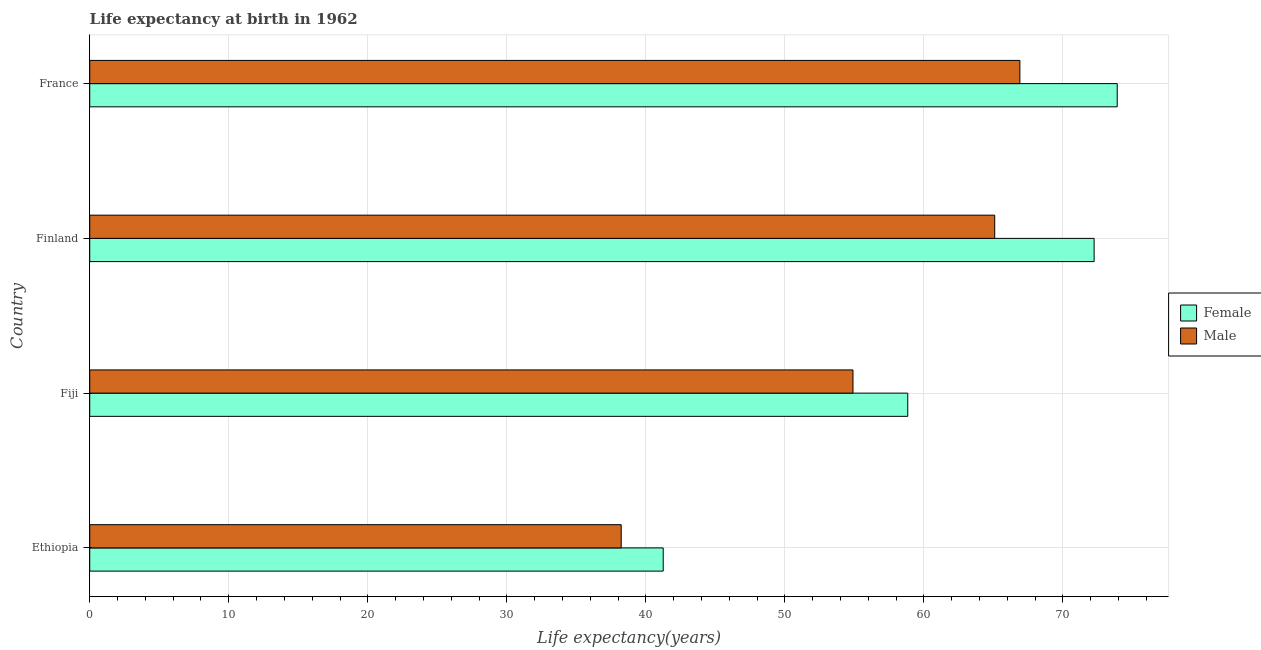How many bars are there on the 4th tick from the top?
Give a very brief answer. 2. How many bars are there on the 3rd tick from the bottom?
Provide a succinct answer. 2. What is the label of the 3rd group of bars from the top?
Provide a short and direct response. Fiji. In how many cases, is the number of bars for a given country not equal to the number of legend labels?
Give a very brief answer. 0. What is the life expectancy(female) in Ethiopia?
Offer a very short reply. 41.25. Across all countries, what is the maximum life expectancy(female)?
Provide a succinct answer. 73.9. Across all countries, what is the minimum life expectancy(female)?
Make the answer very short. 41.25. In which country was the life expectancy(female) maximum?
Your response must be concise. France. In which country was the life expectancy(male) minimum?
Ensure brevity in your answer.  Ethiopia. What is the total life expectancy(female) in the graph?
Make the answer very short. 246.22. What is the difference between the life expectancy(male) in Ethiopia and that in Fiji?
Ensure brevity in your answer.  -16.67. What is the difference between the life expectancy(male) in Finland and the life expectancy(female) in France?
Give a very brief answer. -8.81. What is the average life expectancy(female) per country?
Provide a succinct answer. 61.55. What is the difference between the life expectancy(female) and life expectancy(male) in France?
Offer a terse response. 7. In how many countries, is the life expectancy(male) greater than 22 years?
Your answer should be compact. 4. What is the ratio of the life expectancy(male) in Fiji to that in France?
Offer a terse response. 0.82. Is the difference between the life expectancy(male) in Fiji and France greater than the difference between the life expectancy(female) in Fiji and France?
Make the answer very short. Yes. What is the difference between the highest and the second highest life expectancy(male)?
Your response must be concise. 1.81. What is the difference between the highest and the lowest life expectancy(male)?
Provide a short and direct response. 28.68. What does the 2nd bar from the bottom in France represents?
Ensure brevity in your answer.  Male. How many bars are there?
Keep it short and to the point. 8. What is the difference between two consecutive major ticks on the X-axis?
Offer a terse response. 10. Does the graph contain any zero values?
Make the answer very short. No. Does the graph contain grids?
Offer a terse response. Yes. Where does the legend appear in the graph?
Keep it short and to the point. Center right. How many legend labels are there?
Offer a terse response. 2. What is the title of the graph?
Make the answer very short. Life expectancy at birth in 1962. Does "Register a property" appear as one of the legend labels in the graph?
Offer a terse response. No. What is the label or title of the X-axis?
Your answer should be compact. Life expectancy(years). What is the Life expectancy(years) of Female in Ethiopia?
Give a very brief answer. 41.25. What is the Life expectancy(years) of Male in Ethiopia?
Keep it short and to the point. 38.23. What is the Life expectancy(years) of Female in Fiji?
Your response must be concise. 58.84. What is the Life expectancy(years) of Male in Fiji?
Provide a succinct answer. 54.9. What is the Life expectancy(years) of Female in Finland?
Provide a short and direct response. 72.24. What is the Life expectancy(years) in Male in Finland?
Keep it short and to the point. 65.09. What is the Life expectancy(years) in Female in France?
Offer a terse response. 73.9. What is the Life expectancy(years) of Male in France?
Provide a short and direct response. 66.9. Across all countries, what is the maximum Life expectancy(years) in Female?
Keep it short and to the point. 73.9. Across all countries, what is the maximum Life expectancy(years) in Male?
Your response must be concise. 66.9. Across all countries, what is the minimum Life expectancy(years) of Female?
Keep it short and to the point. 41.25. Across all countries, what is the minimum Life expectancy(years) of Male?
Make the answer very short. 38.23. What is the total Life expectancy(years) of Female in the graph?
Give a very brief answer. 246.22. What is the total Life expectancy(years) of Male in the graph?
Make the answer very short. 225.11. What is the difference between the Life expectancy(years) of Female in Ethiopia and that in Fiji?
Provide a short and direct response. -17.59. What is the difference between the Life expectancy(years) of Male in Ethiopia and that in Fiji?
Offer a very short reply. -16.67. What is the difference between the Life expectancy(years) of Female in Ethiopia and that in Finland?
Provide a short and direct response. -30.99. What is the difference between the Life expectancy(years) of Male in Ethiopia and that in Finland?
Keep it short and to the point. -26.86. What is the difference between the Life expectancy(years) of Female in Ethiopia and that in France?
Provide a short and direct response. -32.65. What is the difference between the Life expectancy(years) of Male in Ethiopia and that in France?
Your response must be concise. -28.68. What is the difference between the Life expectancy(years) of Female in Fiji and that in Finland?
Your response must be concise. -13.4. What is the difference between the Life expectancy(years) of Male in Fiji and that in Finland?
Offer a terse response. -10.19. What is the difference between the Life expectancy(years) of Female in Fiji and that in France?
Offer a very short reply. -15.06. What is the difference between the Life expectancy(years) of Male in Fiji and that in France?
Your answer should be compact. -12. What is the difference between the Life expectancy(years) in Female in Finland and that in France?
Your answer should be compact. -1.66. What is the difference between the Life expectancy(years) of Male in Finland and that in France?
Your response must be concise. -1.81. What is the difference between the Life expectancy(years) in Female in Ethiopia and the Life expectancy(years) in Male in Fiji?
Provide a short and direct response. -13.65. What is the difference between the Life expectancy(years) of Female in Ethiopia and the Life expectancy(years) of Male in Finland?
Provide a short and direct response. -23.84. What is the difference between the Life expectancy(years) in Female in Ethiopia and the Life expectancy(years) in Male in France?
Your answer should be very brief. -25.65. What is the difference between the Life expectancy(years) of Female in Fiji and the Life expectancy(years) of Male in Finland?
Provide a short and direct response. -6.25. What is the difference between the Life expectancy(years) of Female in Fiji and the Life expectancy(years) of Male in France?
Offer a terse response. -8.06. What is the difference between the Life expectancy(years) in Female in Finland and the Life expectancy(years) in Male in France?
Give a very brief answer. 5.34. What is the average Life expectancy(years) in Female per country?
Give a very brief answer. 61.56. What is the average Life expectancy(years) in Male per country?
Give a very brief answer. 56.28. What is the difference between the Life expectancy(years) of Female and Life expectancy(years) of Male in Ethiopia?
Provide a succinct answer. 3.02. What is the difference between the Life expectancy(years) of Female and Life expectancy(years) of Male in Fiji?
Give a very brief answer. 3.94. What is the difference between the Life expectancy(years) of Female and Life expectancy(years) of Male in Finland?
Offer a very short reply. 7.15. What is the ratio of the Life expectancy(years) in Female in Ethiopia to that in Fiji?
Provide a succinct answer. 0.7. What is the ratio of the Life expectancy(years) of Male in Ethiopia to that in Fiji?
Keep it short and to the point. 0.7. What is the ratio of the Life expectancy(years) in Female in Ethiopia to that in Finland?
Your answer should be very brief. 0.57. What is the ratio of the Life expectancy(years) in Male in Ethiopia to that in Finland?
Your answer should be very brief. 0.59. What is the ratio of the Life expectancy(years) in Female in Ethiopia to that in France?
Offer a terse response. 0.56. What is the ratio of the Life expectancy(years) of Male in Ethiopia to that in France?
Ensure brevity in your answer.  0.57. What is the ratio of the Life expectancy(years) of Female in Fiji to that in Finland?
Your answer should be compact. 0.81. What is the ratio of the Life expectancy(years) of Male in Fiji to that in Finland?
Offer a very short reply. 0.84. What is the ratio of the Life expectancy(years) of Female in Fiji to that in France?
Provide a succinct answer. 0.8. What is the ratio of the Life expectancy(years) of Male in Fiji to that in France?
Provide a short and direct response. 0.82. What is the ratio of the Life expectancy(years) in Female in Finland to that in France?
Your answer should be compact. 0.98. What is the ratio of the Life expectancy(years) of Male in Finland to that in France?
Provide a short and direct response. 0.97. What is the difference between the highest and the second highest Life expectancy(years) of Female?
Provide a short and direct response. 1.66. What is the difference between the highest and the second highest Life expectancy(years) of Male?
Offer a very short reply. 1.81. What is the difference between the highest and the lowest Life expectancy(years) of Female?
Your response must be concise. 32.65. What is the difference between the highest and the lowest Life expectancy(years) of Male?
Give a very brief answer. 28.68. 